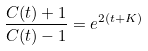Convert formula to latex. <formula><loc_0><loc_0><loc_500><loc_500>\frac { C ( t ) + 1 } { C ( t ) - 1 } = e ^ { 2 ( t + K ) }</formula> 